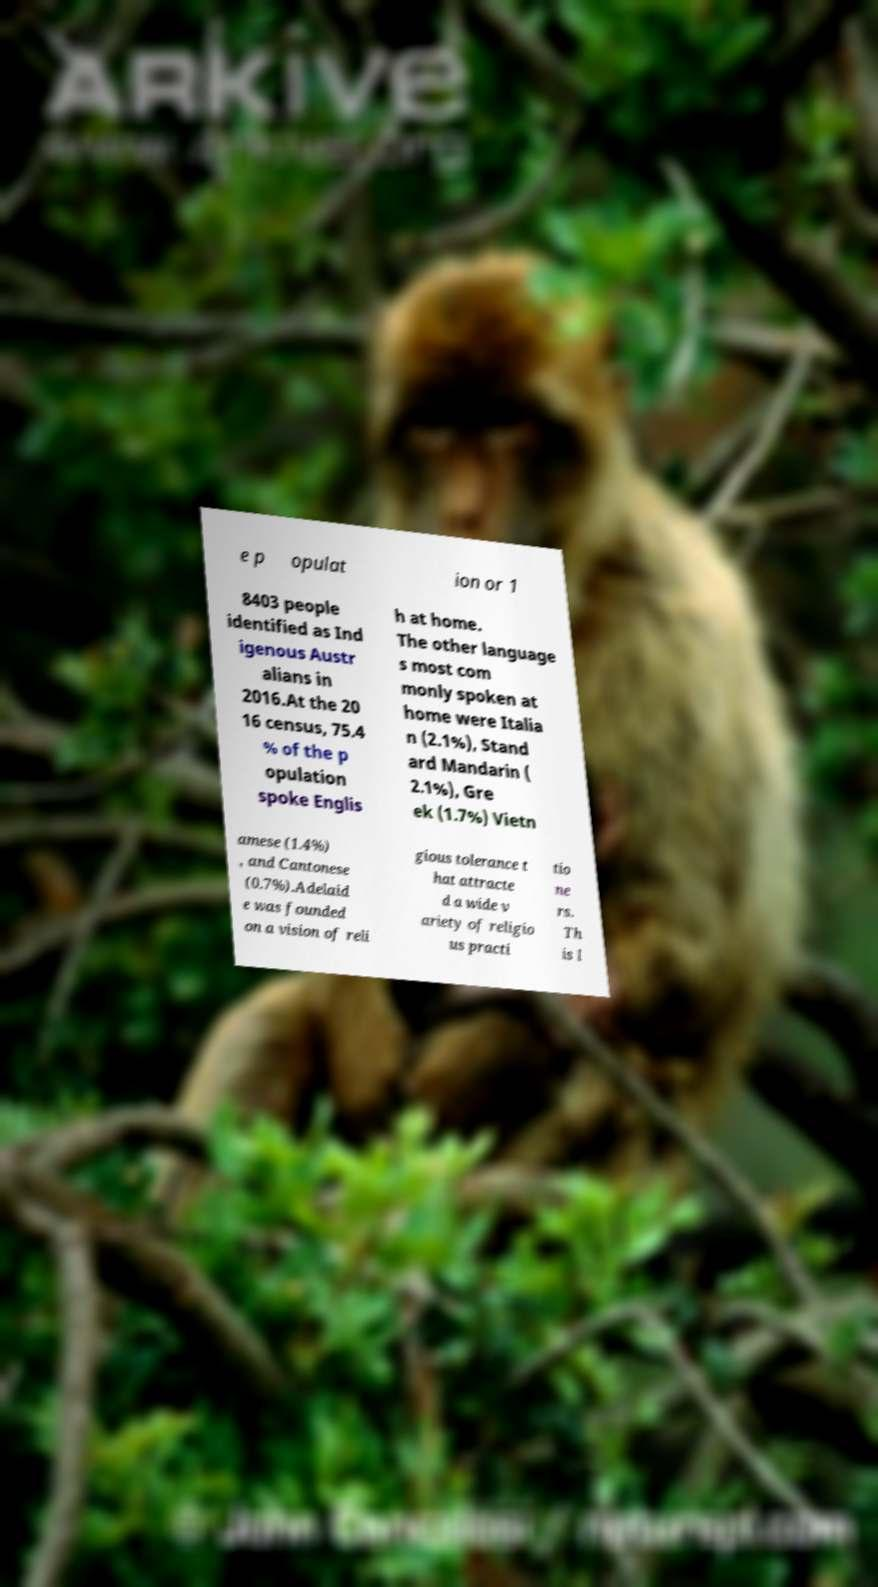Could you assist in decoding the text presented in this image and type it out clearly? e p opulat ion or 1 8403 people identified as Ind igenous Austr alians in 2016.At the 20 16 census, 75.4 % of the p opulation spoke Englis h at home. The other language s most com monly spoken at home were Italia n (2.1%), Stand ard Mandarin ( 2.1%), Gre ek (1.7%) Vietn amese (1.4%) , and Cantonese (0.7%).Adelaid e was founded on a vision of reli gious tolerance t hat attracte d a wide v ariety of religio us practi tio ne rs. Th is l 